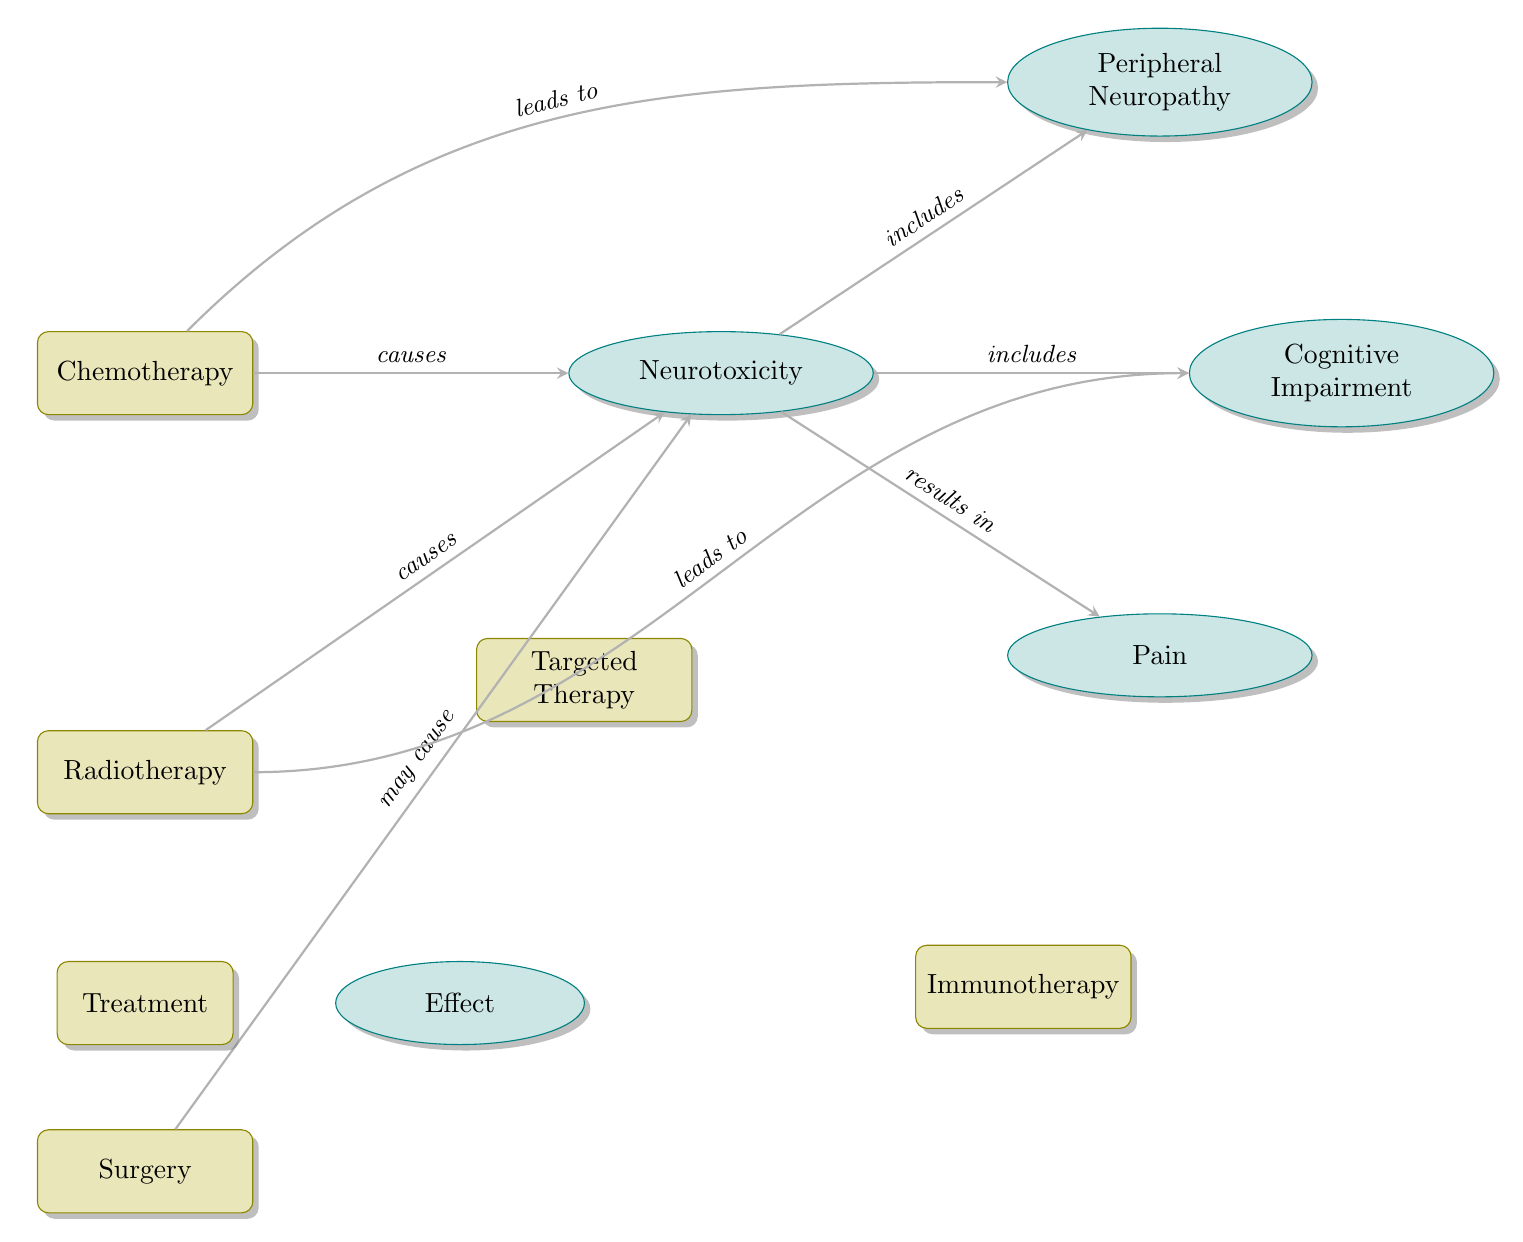What's the first treatment modality listed in the diagram? The first treatment modality is located at the top of the treatment nodes, which is "Chemotherapy."
Answer: Chemotherapy How many treatment modalities are shown in the diagram? Counting the treatment nodes in the diagram, there are a total of five modalities: Chemotherapy, Radiotherapy, Surgery, Targeted Therapy, and Immunotherapy.
Answer: Five Which treatment modality leads to Cognitive Impairment? Following the arrow from the Radiotherapy node, it indicates that this treatment modality causes Cognitive Impairment as one of its effects.
Answer: Radiotherapy What type of effect is identified as Neurotoxicity? To identify the effect type, we see in the diagram that Neurotoxicity is classified under "Effect," as it is depicted by an elliptical shape.
Answer: Effect Which treatment modalities may cause Neurotoxicity? The treatments that are shown to cause Neurotoxicity are Chemotherapy and Radiotherapy, while Surgery may cause it.
Answer: Chemotherapy and Radiotherapy How does Chemotherapy relate to Peripheral Neuropathy? The diagram indicates that Chemotherapy leads to Peripheral Neuropathy through a directed arrow that states "leads to."
Answer: Leads to What effect is directly related to Neurotoxicity? The effects included under Neurotoxicity are Peripheral Neuropathy, Cognitive Impairment, and Pain as shown by the arrows leading from the Neurotoxicity node.
Answer: Peripheral Neuropathy, Cognitive Impairment, and Pain What is the relationship between Radiotherapy and Neurotoxicity? The relationship is indicated by a directed arrow stating "causes," meaning that Radiotherapy has a direct effect of causing Neurotoxicity.
Answer: Causes Which treatment modality is positioned below Radiotherapy? Looking at the diagram, the treatment modality positioned directly below Radiotherapy is Surgery.
Answer: Surgery 